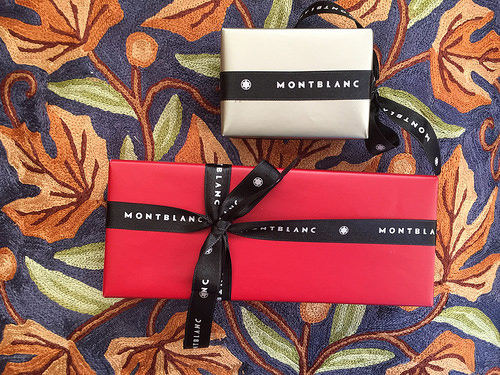<image>
Is the box above the box? No. The box is not positioned above the box. The vertical arrangement shows a different relationship. 